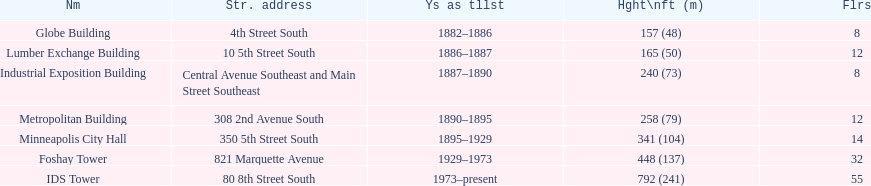What was the length of time during which the lumber exchange building remained the tallest building? 1 year. 